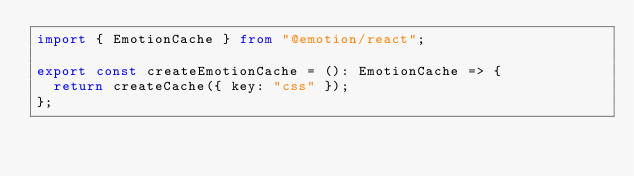<code> <loc_0><loc_0><loc_500><loc_500><_TypeScript_>import { EmotionCache } from "@emotion/react";

export const createEmotionCache = (): EmotionCache => {
  return createCache({ key: "css" });
};
</code> 